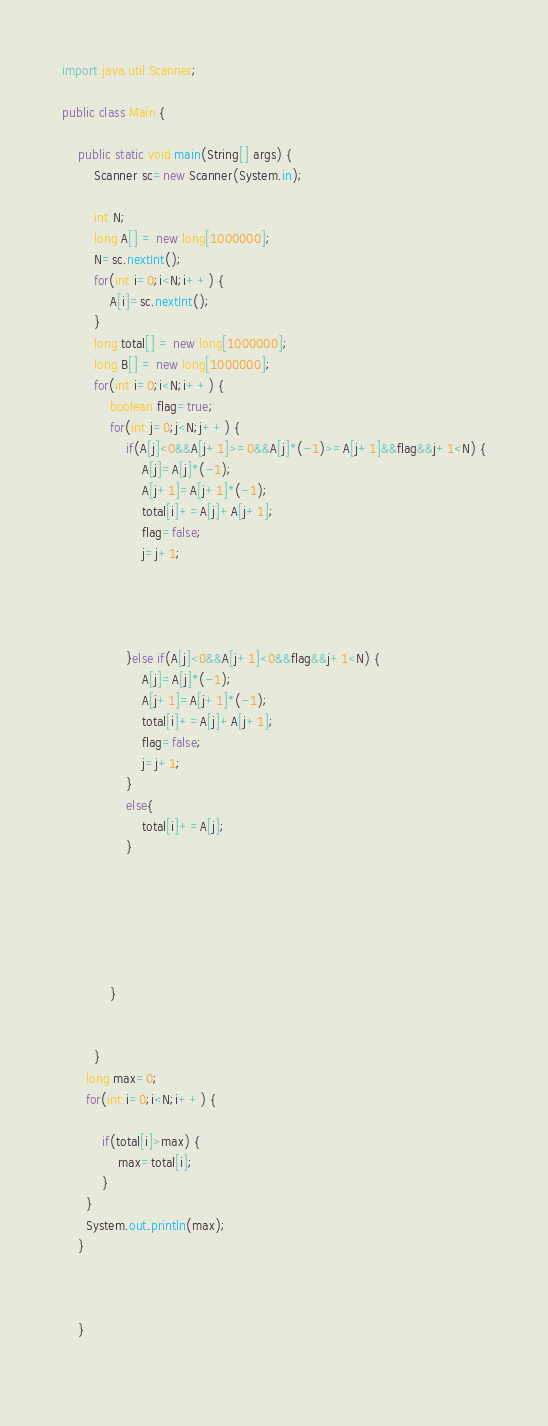<code> <loc_0><loc_0><loc_500><loc_500><_Java_>import java.util.Scanner;

public class Main {

	public static void main(String[] args) {
		Scanner sc=new Scanner(System.in);
		
		int N;
		long A[] = new long[1000000];
		N=sc.nextInt();
		for(int i=0;i<N;i++) {
			A[i]=sc.nextInt();
		}
		long total[] = new long[1000000];
		long B[] = new long[1000000];
		for(int i=0;i<N;i++) {
			boolean flag=true;
			for(int j=0;j<N;j++) {
				if(A[j]<0&&A[j+1]>=0&&A[j]*(-1)>=A[j+1]&&flag&&j+1<N) {
					A[j]=A[j]*(-1);
					A[j+1]=A[j+1]*(-1);
					total[i]+=A[j]+A[j+1];
					flag=false;
					j=j+1;
					
					
				
					
				}else if(A[j]<0&&A[j+1]<0&&flag&&j+1<N) {
					A[j]=A[j]*(-1);
					A[j+1]=A[j+1]*(-1);
					total[i]+=A[j]+A[j+1];
					flag=false;
					j=j+1;
				}
				else{
					total[i]+=A[j];
				}
				
				
					
				
					
				
			}
			
			
		}
	  long max=0;
	  for(int i=0;i<N;i++) {
		  
		  if(total[i]>max) {
			  max=total[i];
		  }
	  }
	  System.out.println(max);
	}
	
	
		
	}
		</code> 